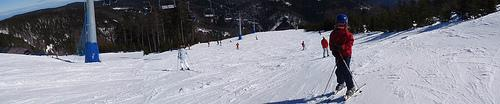What are some of the recreational activities happening in the frame? Skiing and ski-skating are some of the recreational activities happening in the frame. Can you see any natural features in the image? If so, what are they? Yes, trees and mountains can be seen in the image. Count the number of skiers wearing red in the image. There are two skiers wearing red. Mention two objects from the image that are blue. A blue helmet and a blue electrical pole are two objects in the image. Provide a brief overview of the overall scene captured in the image. The image captures a busy ski slope filled with people skiing, surrounded by trees and mountains. Discuss the overall mood or sentiment of the image. The image conveys a lively and active mood, as many people are enjoying outdoor recreational activities in a beautiful winter setting. Please describe the weather conditions in the image. It is a clear winter day with snow covering the ground. What type of terrain is the main subject located on? The main subject is located on a snow-covered ski slope. Identify a prominent color in a piece of clothing worn by the main skier. Red is the prominent color in the skier's jacket. What type of headgear is the main skier wearing? The main skier is wearing a blue helmet. What can you see beyond the ski resort? Mountains How does the woman maintain balance while skiing? Using ski poles What type of image is it? A panoramic image What is the color of the pants worn by the woman? Black Identify the type of pole with blue trim. An electrical pole What type of headgear is the woman wearing? A helmet Does the man in the red jacket have a green helmet? The image mentions a skier with a red jacket and a blue helmet, but there is no mention of a green helmet. Is there a snowman in the background? The image describes various aspects of the ski resort, mountains, trees, and people, but there is no mention of a snowman. Which color is the jacket of the skier mentioned in the captions? Red Is there any evidence of an activity taking place at the ski resort? Yes, many people are skiing at the resort. Describe the ground condition at the ski resort. The ground is covered with thick snow. Comment on the weather shown in the image. It is a clear winter day. State what is visible in the horizon. Mountains Identify the interaction between the woman skier and her ski poles. The woman is holding ski poles. Is the woman wearing sunglasses? (yes/no) Yes What is the color combination of the electrical pole? Blue and grey Can you see trees in the ski arena? Yes, trees are lining up the ski arena. Are the skis in the picture pink? No, it's not mentioned in the image. Can you spot the snowboarder? The image is specifically about skiing and the captions mention skiers and ski equipment, not snowboarding or snowboarders. Does the electric pole have a purple stripe? The image has a blue and grey electric pole, but there is no mention of a purple stripe. What is the color of the helmet worn by the boy? Blue How many skiers are wearing red? Two Is there a dog playing in the snow? The image contains numerous captions about skiers, snow, and the environment, but there is no mention of a dog. Describe the ski slope. The ski slope is busy with many people visiting the ski resort. 